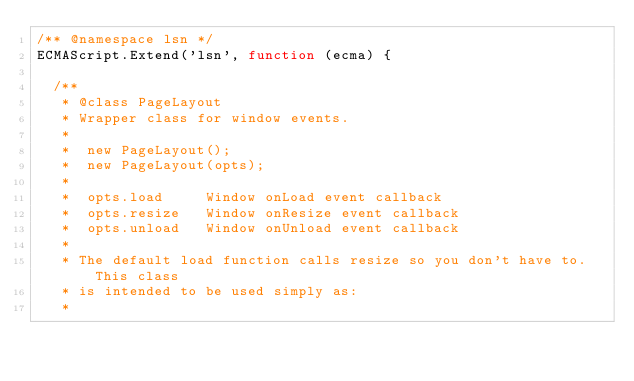Convert code to text. <code><loc_0><loc_0><loc_500><loc_500><_JavaScript_>/** @namespace lsn */
ECMAScript.Extend('lsn', function (ecma) {

  /**
   * @class PageLayout
   * Wrapper class for window events.
   *
   *  new PageLayout();
   *  new PageLayout(opts);
   *
   *  opts.load     Window onLoad event callback
   *  opts.resize   Window onResize event callback
   *  opts.unload   Window onUnload event callback
   *
   * The default load function calls resize so you don't have to.  This class
   * is intended to be used simply as:
   * </code> 